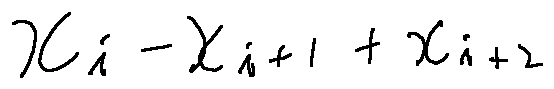<formula> <loc_0><loc_0><loc_500><loc_500>x _ { i } - x _ { i + 1 } + x _ { i + 2 }</formula> 